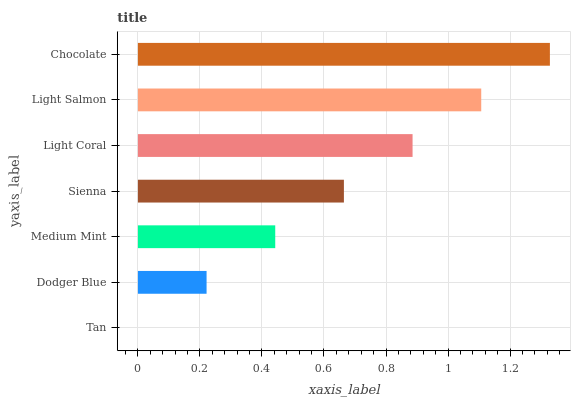Is Tan the minimum?
Answer yes or no. Yes. Is Chocolate the maximum?
Answer yes or no. Yes. Is Dodger Blue the minimum?
Answer yes or no. No. Is Dodger Blue the maximum?
Answer yes or no. No. Is Dodger Blue greater than Tan?
Answer yes or no. Yes. Is Tan less than Dodger Blue?
Answer yes or no. Yes. Is Tan greater than Dodger Blue?
Answer yes or no. No. Is Dodger Blue less than Tan?
Answer yes or no. No. Is Sienna the high median?
Answer yes or no. Yes. Is Sienna the low median?
Answer yes or no. Yes. Is Light Coral the high median?
Answer yes or no. No. Is Light Coral the low median?
Answer yes or no. No. 